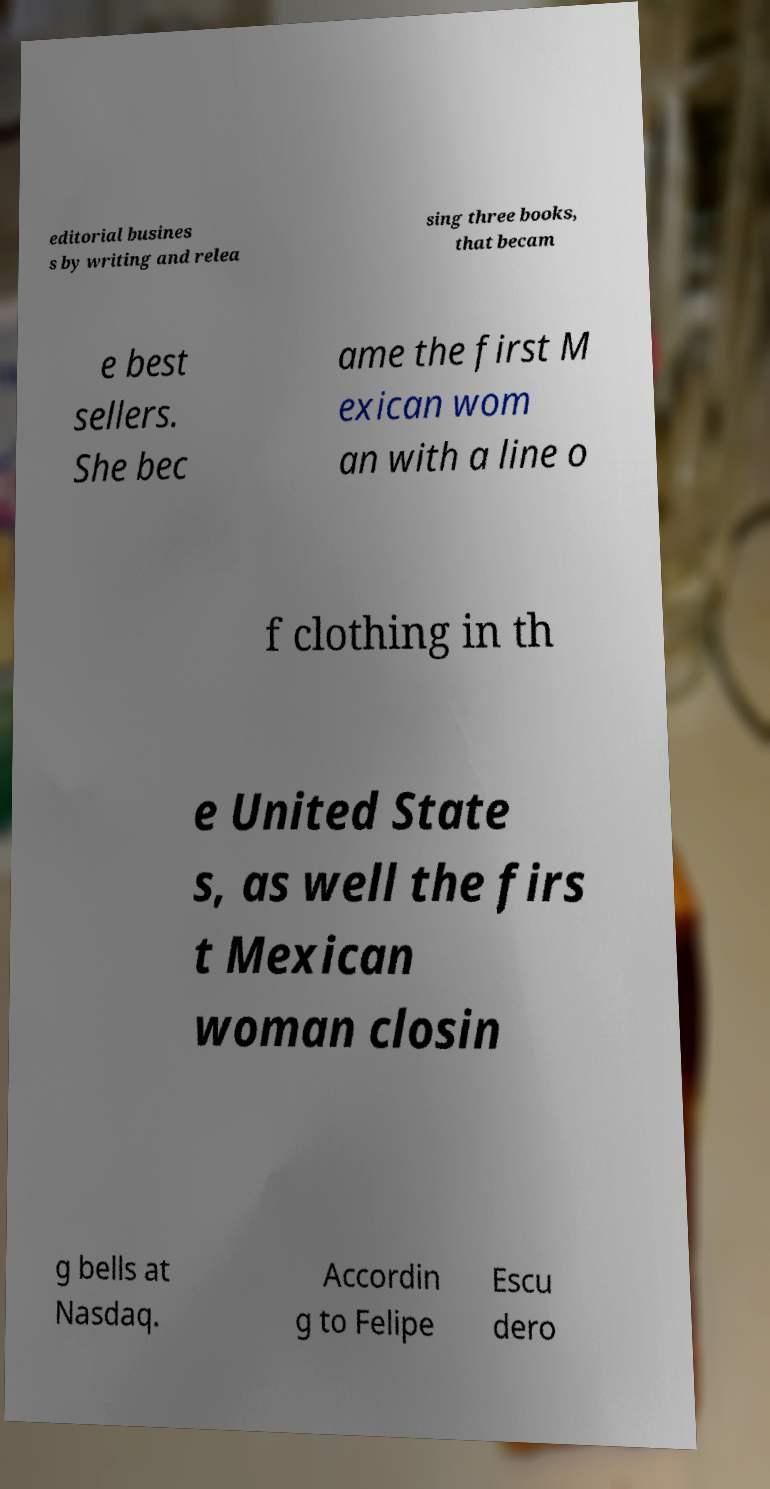Could you assist in decoding the text presented in this image and type it out clearly? editorial busines s by writing and relea sing three books, that becam e best sellers. She bec ame the first M exican wom an with a line o f clothing in th e United State s, as well the firs t Mexican woman closin g bells at Nasdaq. Accordin g to Felipe Escu dero 